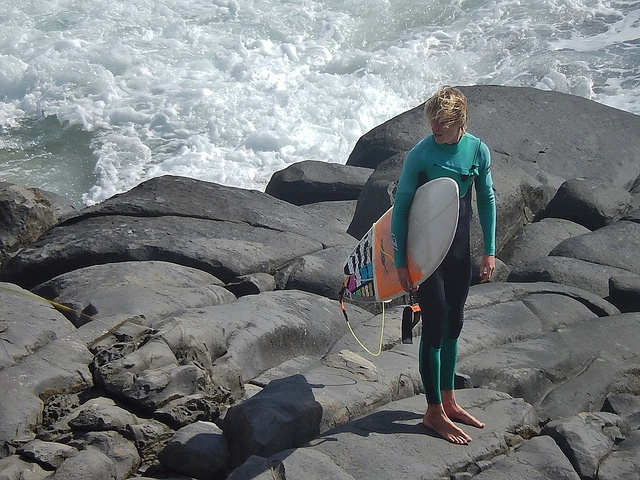Describe the objects in this image and their specific colors. I can see people in darkgray, black, gray, and teal tones and surfboard in darkgray, gray, brown, and black tones in this image. 